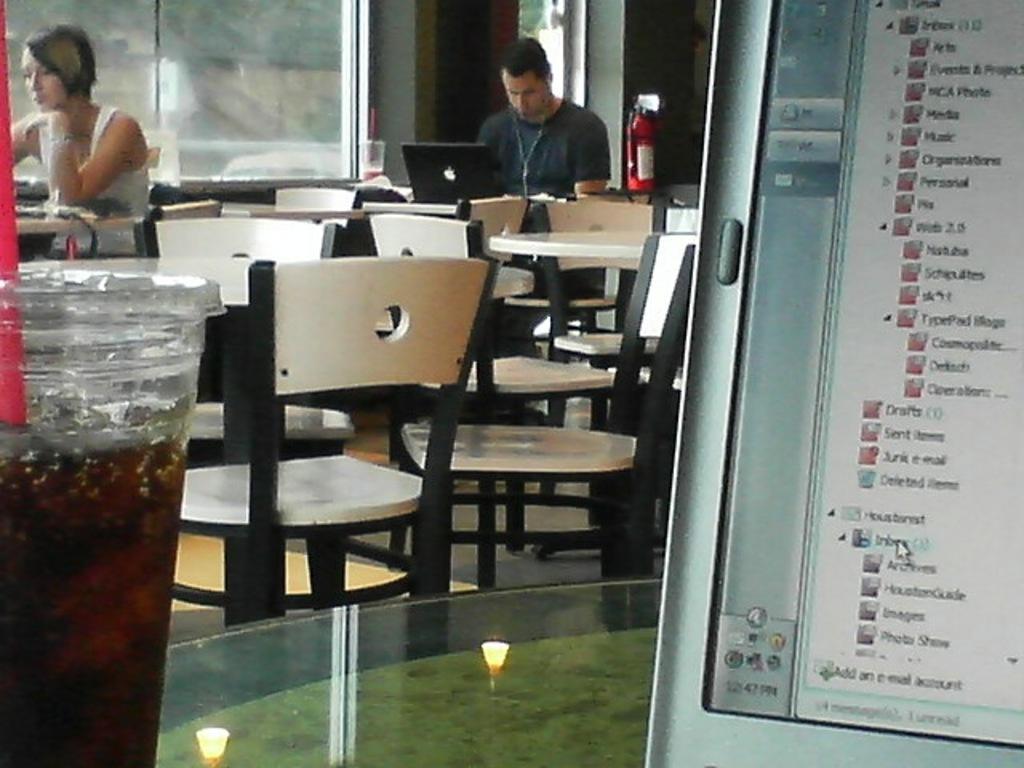In one or two sentences, can you explain what this image depicts? In the image there is a woman and guy sat on chair,this image seems to be inside a hotel and there is a screen over the right side and a soft drink bottle over left side. 